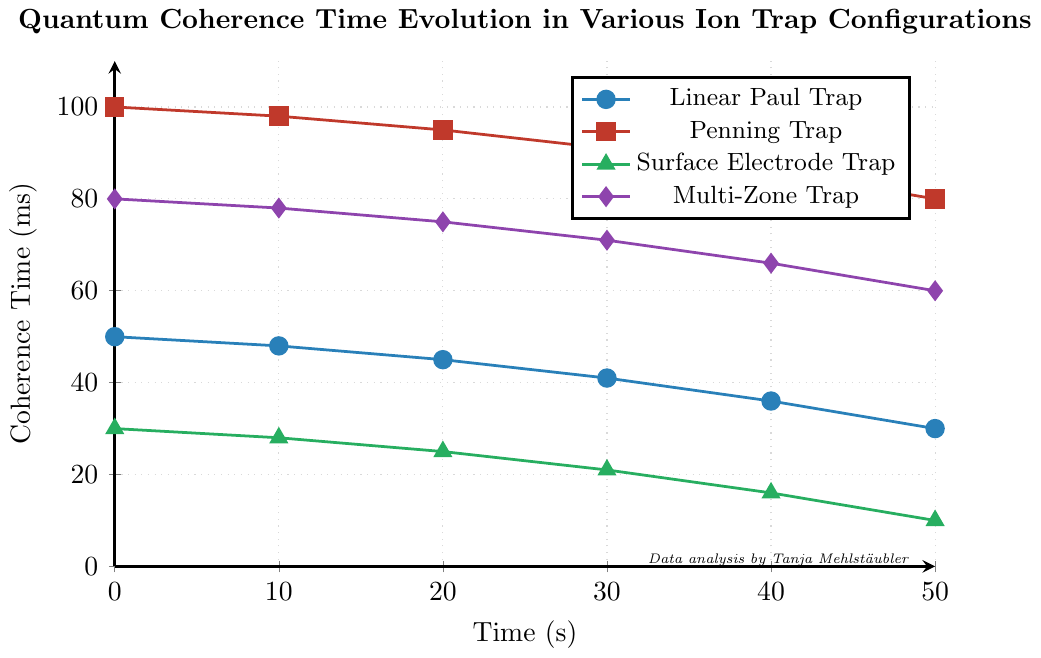How does the coherence time of the Linear Paul Trap change over the first 20 seconds? In the first 20 seconds, the coherence time for the Linear Paul Trap drops from 50 ms to 45 ms, which is a decrease of 5 ms.
Answer: It decreases by 5 ms Which ion trap configuration shows the highest initial coherence time and what is its value? By observing the starting point of each configuration on the Y-axis (coherence time), we see that the Penning Trap starts at the highest value of 100 ms.
Answer: Penning Trap with 100 ms After 50 seconds, which ion trap configuration retains the highest coherence time? At the 50-second mark, comparing the Y-values of the configurations, the Penning Trap retains a coherence time of 80 ms, which is the highest.
Answer: Penning Trap Which configuration experiences the most significant drop in coherence time in the first 50 seconds, and what is the magnitude of this drop? By calculating the initial and final coherence times, we see that the Surface Electrode Trap drops from 30 ms to 10 ms, a decrease of 20 ms.
Answer: Surface Electrode Trap, 20 ms Compare the coherence time of the Multi-Zone Trap and Linear Paul Trap at 30 seconds. Which one is higher? Looking at the 30-second mark, the coherence time for the Multi-Zone Trap is 71 ms, and for the Linear Paul Trap, it is 41 ms. Therefore, the Multi-Zone Trap has a higher coherence time.
Answer: Multi-Zone Trap What is the average coherence time of the Penning Trap over the 50 seconds? By summing the coherence times at 0s, 10s, 20s, 30s, 40s, and 50s: (100 + 98 + 95 + 91 + 86 + 80) = 550 ms. Dividing by 6 (number of data points), the average coherence time is approximately 91.67 ms.
Answer: 91.67 ms Which ion trap configuration has the steepest decline in coherence time in the first 20 seconds? Comparing the drop in coherence time from 0 to 20 seconds, the Surface Electrode Trap drops from 30 ms to 25 ms (5 ms), the Linear Paul Trap from 50 ms to 45 ms (5 ms), the Penning Trap from 100 ms to 95 ms (5 ms), and the Multi-Zone Trap from 80 ms to 75 ms (5 ms). The steepness is the same across all configurations, all have a 5 ms drop.
Answer: All configurations (5 ms drop) Which ion trap configuration has the least fluctuation in coherence time over the entire time period? By observing the coherence times' consistency and change, the Penning Trap changes from 100 ms to 80 ms, which is the smallest range compared to others.
Answer: Penning Trap How does the average coherence time of the Surface Electrode Trap compare to the Linear Paul Trap over the 50 seconds? Summing the coherence times for Surface Electrode Trap: (30 + 28 + 25 + 21 + 16 + 10) = 130 ms; for Linear Paul Trap: (50 + 48 + 45 + 41 + 36 + 30) = 250 ms. The average coherence time for the Surface Electrode Trap is 130/6 ≈ 21.67 ms, and for the Linear Paul Trap, it is 250/6 ≈ 41.67 ms. Therefore, the Linear Paul Trap has a higher average coherence time.
Answer: The Linear Paul Trap is higher 